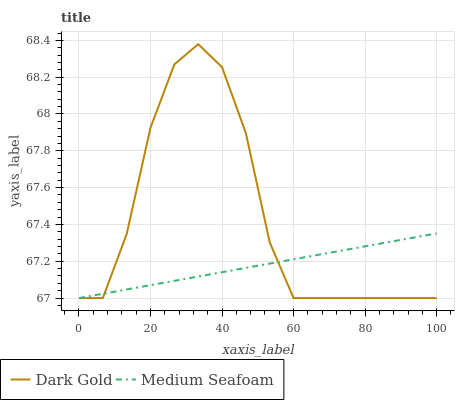Does Medium Seafoam have the minimum area under the curve?
Answer yes or no. Yes. Does Dark Gold have the maximum area under the curve?
Answer yes or no. Yes. Does Dark Gold have the minimum area under the curve?
Answer yes or no. No. Is Medium Seafoam the smoothest?
Answer yes or no. Yes. Is Dark Gold the roughest?
Answer yes or no. Yes. Is Dark Gold the smoothest?
Answer yes or no. No. Does Medium Seafoam have the lowest value?
Answer yes or no. Yes. Does Dark Gold have the highest value?
Answer yes or no. Yes. Does Medium Seafoam intersect Dark Gold?
Answer yes or no. Yes. Is Medium Seafoam less than Dark Gold?
Answer yes or no. No. Is Medium Seafoam greater than Dark Gold?
Answer yes or no. No. 